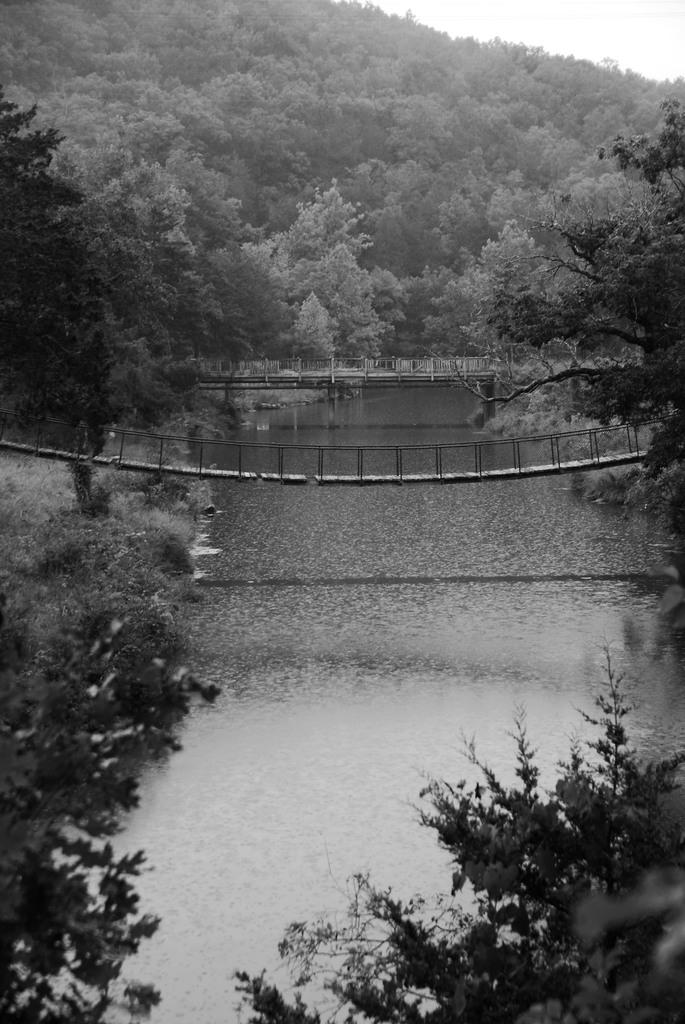What type of natural elements can be seen in the image? There are trees and water visible in the image. What structures are present in the image? There are bridges in the image. What can be seen in the background of the image? The sky is visible in the background of the image. What type of produce is being sold at the observation deck in the image? There is no observation deck or produce present in the image. 